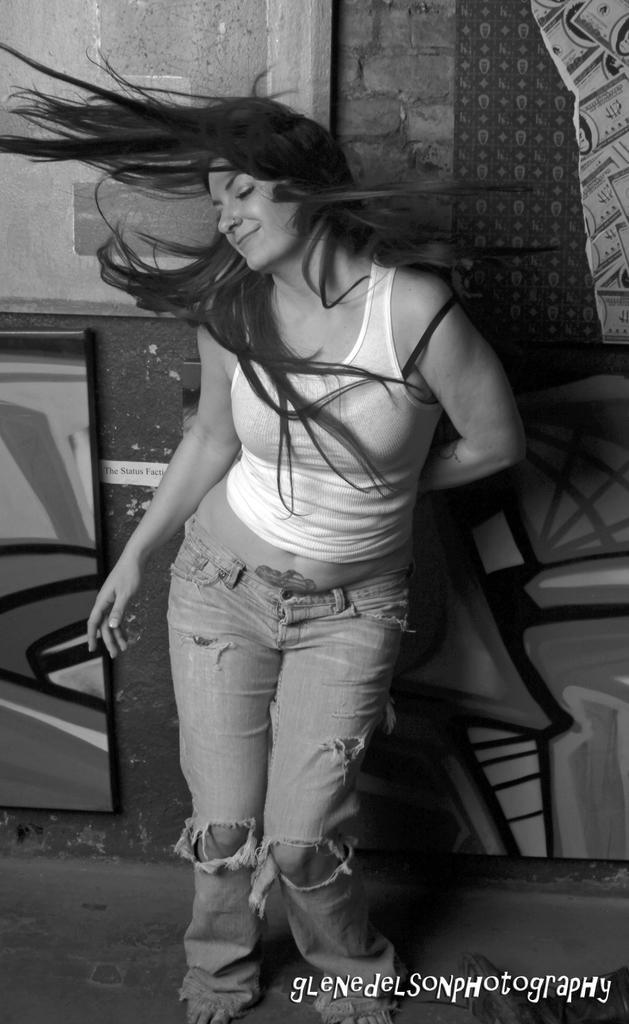How would you summarize this image in a sentence or two? It is a black and white image. In this image at front there is a person standing on the floor. At the back side there is a wall. 